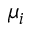Convert formula to latex. <formula><loc_0><loc_0><loc_500><loc_500>\mu _ { i }</formula> 